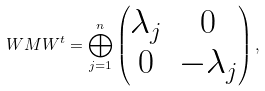Convert formula to latex. <formula><loc_0><loc_0><loc_500><loc_500>W M W ^ { t } = \bigoplus _ { j = 1 } ^ { n } \begin{pmatrix} \lambda _ { j } & 0 \\ 0 & - \lambda _ { j } \\ \end{pmatrix} ,</formula> 